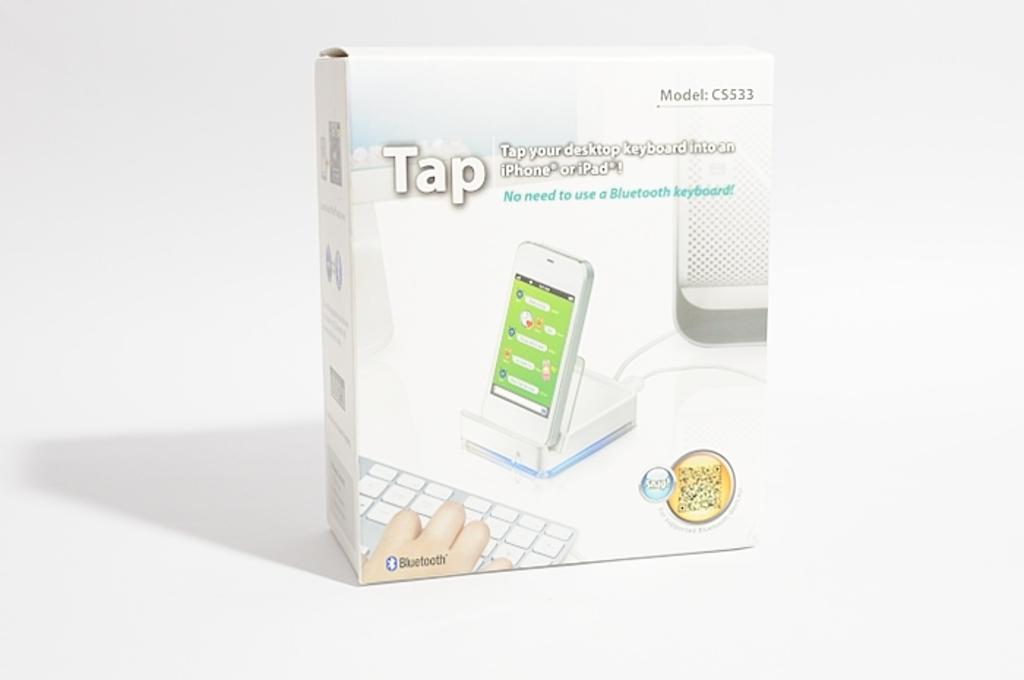<image>
Summarize the visual content of the image. The box shows a computer tied to a phone and keyboard that is sold by Tap. 